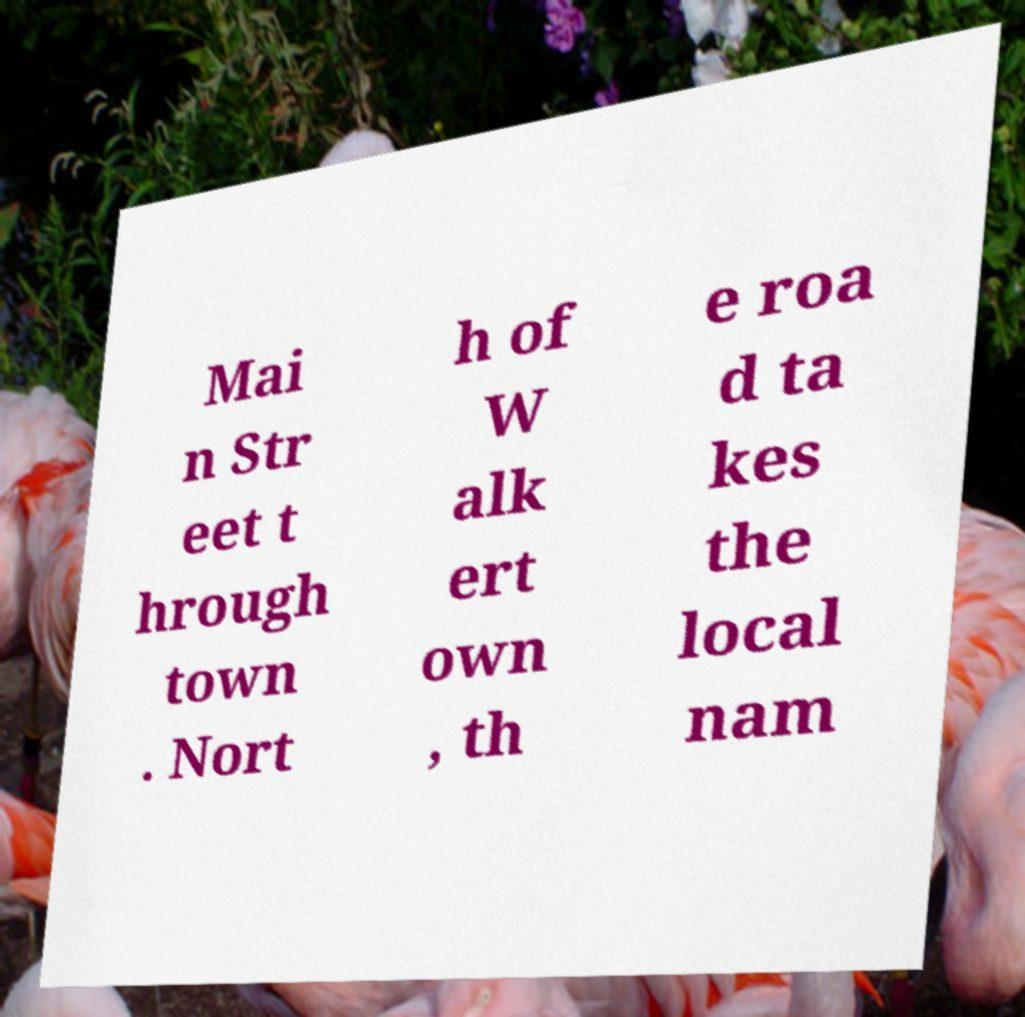Can you read and provide the text displayed in the image?This photo seems to have some interesting text. Can you extract and type it out for me? Mai n Str eet t hrough town . Nort h of W alk ert own , th e roa d ta kes the local nam 